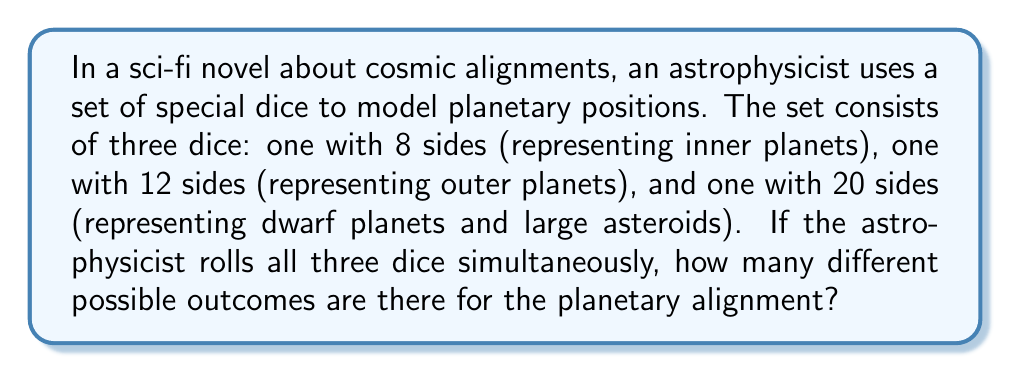Show me your answer to this math problem. To solve this problem, we need to use the multiplication principle of counting. This principle states that if we have multiple independent events, the total number of possible outcomes is the product of the number of possibilities for each event.

Let's break down the problem:

1. The 8-sided die (inner planets) has 8 possible outcomes.
2. The 12-sided die (outer planets) has 12 possible outcomes.
3. The 20-sided die (dwarf planets and large asteroids) has 20 possible outcomes.

Since the rolls are independent of each other, we multiply the number of possibilities for each die:

$$ \text{Total outcomes} = 8 \times 12 \times 20 $$

Now, let's calculate:

$$ \begin{align}
\text{Total outcomes} &= 8 \times 12 \times 20 \\
&= 96 \times 20 \\
&= 1,920
\end{align} $$

This result can be interpreted in the context of the sci-fi novel as follows: there are 1,920 unique planetary alignments that can be modeled using this set of dice. Each alignment represents a specific combination of positions for the inner planets, outer planets, and dwarf planets/large asteroids.

In astrophysical terms, this simplified model demonstrates the vast number of possible configurations in our solar system, even when reduced to just three categories of celestial bodies. It highlights the complexity of planetary motion and the rarity of specific alignments, which could be a crucial plot point in a scientifically accurate sci-fi novel.
Answer: $$ 1,920 \text{ possible outcomes} $$ 